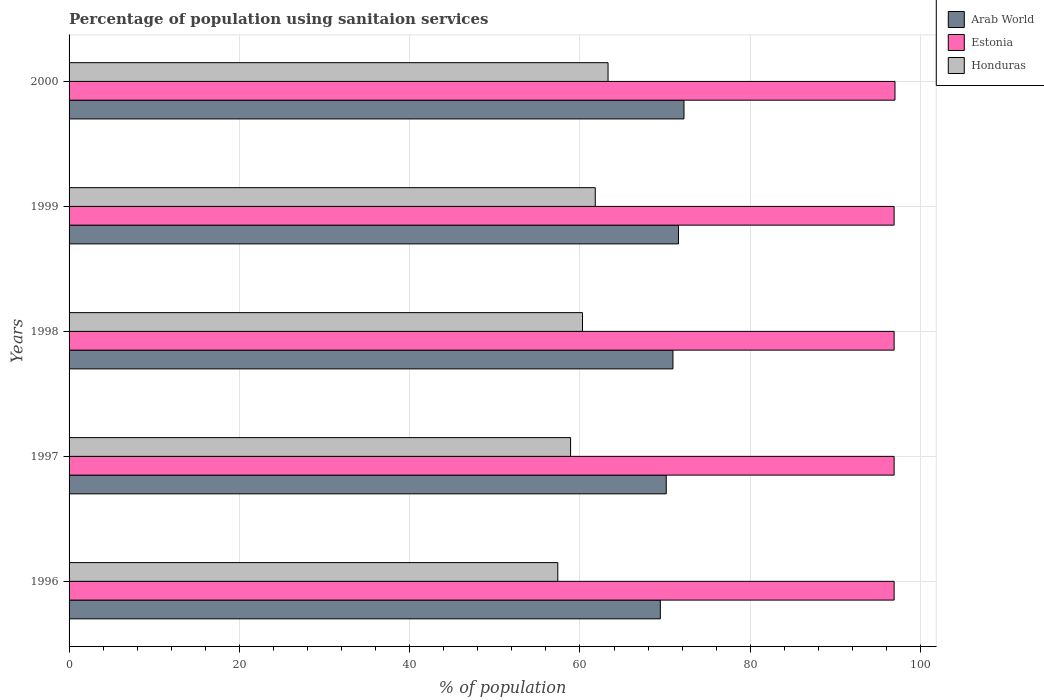How many different coloured bars are there?
Keep it short and to the point. 3. What is the label of the 4th group of bars from the top?
Provide a succinct answer. 1997. What is the percentage of population using sanitaion services in Estonia in 1998?
Provide a succinct answer. 96.9. Across all years, what is the maximum percentage of population using sanitaion services in Estonia?
Your answer should be compact. 97. Across all years, what is the minimum percentage of population using sanitaion services in Arab World?
Ensure brevity in your answer.  69.44. What is the total percentage of population using sanitaion services in Arab World in the graph?
Your response must be concise. 354.29. What is the difference between the percentage of population using sanitaion services in Arab World in 1996 and that in 1997?
Keep it short and to the point. -0.7. What is the difference between the percentage of population using sanitaion services in Honduras in 2000 and the percentage of population using sanitaion services in Arab World in 1997?
Your answer should be very brief. -6.84. What is the average percentage of population using sanitaion services in Honduras per year?
Ensure brevity in your answer.  60.34. In the year 2000, what is the difference between the percentage of population using sanitaion services in Honduras and percentage of population using sanitaion services in Arab World?
Your answer should be very brief. -8.92. In how many years, is the percentage of population using sanitaion services in Arab World greater than 36 %?
Make the answer very short. 5. What is the ratio of the percentage of population using sanitaion services in Honduras in 1997 to that in 1998?
Give a very brief answer. 0.98. What is the difference between the highest and the second highest percentage of population using sanitaion services in Estonia?
Your answer should be very brief. 0.1. What is the difference between the highest and the lowest percentage of population using sanitaion services in Estonia?
Make the answer very short. 0.1. Is the sum of the percentage of population using sanitaion services in Honduras in 1999 and 2000 greater than the maximum percentage of population using sanitaion services in Arab World across all years?
Provide a short and direct response. Yes. What does the 3rd bar from the top in 1998 represents?
Offer a terse response. Arab World. What does the 3rd bar from the bottom in 2000 represents?
Your answer should be compact. Honduras. Are all the bars in the graph horizontal?
Keep it short and to the point. Yes. How many years are there in the graph?
Make the answer very short. 5. Are the values on the major ticks of X-axis written in scientific E-notation?
Give a very brief answer. No. Does the graph contain grids?
Give a very brief answer. Yes. Where does the legend appear in the graph?
Give a very brief answer. Top right. How are the legend labels stacked?
Your response must be concise. Vertical. What is the title of the graph?
Provide a succinct answer. Percentage of population using sanitaion services. Does "Monaco" appear as one of the legend labels in the graph?
Ensure brevity in your answer.  No. What is the label or title of the X-axis?
Provide a succinct answer. % of population. What is the % of population in Arab World in 1996?
Provide a short and direct response. 69.44. What is the % of population in Estonia in 1996?
Provide a succinct answer. 96.9. What is the % of population in Honduras in 1996?
Make the answer very short. 57.4. What is the % of population of Arab World in 1997?
Your answer should be very brief. 70.14. What is the % of population in Estonia in 1997?
Your answer should be very brief. 96.9. What is the % of population in Honduras in 1997?
Provide a succinct answer. 58.9. What is the % of population in Arab World in 1998?
Provide a short and direct response. 70.92. What is the % of population of Estonia in 1998?
Provide a short and direct response. 96.9. What is the % of population in Honduras in 1998?
Provide a succinct answer. 60.3. What is the % of population in Arab World in 1999?
Keep it short and to the point. 71.57. What is the % of population of Estonia in 1999?
Ensure brevity in your answer.  96.9. What is the % of population in Honduras in 1999?
Give a very brief answer. 61.8. What is the % of population in Arab World in 2000?
Provide a succinct answer. 72.22. What is the % of population of Estonia in 2000?
Make the answer very short. 97. What is the % of population of Honduras in 2000?
Ensure brevity in your answer.  63.3. Across all years, what is the maximum % of population of Arab World?
Keep it short and to the point. 72.22. Across all years, what is the maximum % of population in Estonia?
Your answer should be compact. 97. Across all years, what is the maximum % of population of Honduras?
Offer a very short reply. 63.3. Across all years, what is the minimum % of population of Arab World?
Provide a short and direct response. 69.44. Across all years, what is the minimum % of population in Estonia?
Ensure brevity in your answer.  96.9. Across all years, what is the minimum % of population in Honduras?
Give a very brief answer. 57.4. What is the total % of population of Arab World in the graph?
Keep it short and to the point. 354.29. What is the total % of population of Estonia in the graph?
Make the answer very short. 484.6. What is the total % of population of Honduras in the graph?
Make the answer very short. 301.7. What is the difference between the % of population of Arab World in 1996 and that in 1997?
Your response must be concise. -0.7. What is the difference between the % of population in Estonia in 1996 and that in 1997?
Your response must be concise. 0. What is the difference between the % of population of Honduras in 1996 and that in 1997?
Your response must be concise. -1.5. What is the difference between the % of population in Arab World in 1996 and that in 1998?
Give a very brief answer. -1.48. What is the difference between the % of population of Estonia in 1996 and that in 1998?
Ensure brevity in your answer.  0. What is the difference between the % of population in Arab World in 1996 and that in 1999?
Make the answer very short. -2.13. What is the difference between the % of population of Honduras in 1996 and that in 1999?
Ensure brevity in your answer.  -4.4. What is the difference between the % of population of Arab World in 1996 and that in 2000?
Keep it short and to the point. -2.78. What is the difference between the % of population of Estonia in 1996 and that in 2000?
Your answer should be compact. -0.1. What is the difference between the % of population in Arab World in 1997 and that in 1998?
Offer a very short reply. -0.79. What is the difference between the % of population in Arab World in 1997 and that in 1999?
Your response must be concise. -1.44. What is the difference between the % of population of Honduras in 1997 and that in 1999?
Provide a succinct answer. -2.9. What is the difference between the % of population of Arab World in 1997 and that in 2000?
Offer a very short reply. -2.08. What is the difference between the % of population of Estonia in 1997 and that in 2000?
Provide a short and direct response. -0.1. What is the difference between the % of population of Honduras in 1997 and that in 2000?
Ensure brevity in your answer.  -4.4. What is the difference between the % of population of Arab World in 1998 and that in 1999?
Make the answer very short. -0.65. What is the difference between the % of population in Estonia in 1998 and that in 1999?
Your answer should be very brief. 0. What is the difference between the % of population of Arab World in 1998 and that in 2000?
Your answer should be compact. -1.29. What is the difference between the % of population of Arab World in 1999 and that in 2000?
Your answer should be very brief. -0.65. What is the difference between the % of population in Estonia in 1999 and that in 2000?
Ensure brevity in your answer.  -0.1. What is the difference between the % of population in Honduras in 1999 and that in 2000?
Provide a short and direct response. -1.5. What is the difference between the % of population in Arab World in 1996 and the % of population in Estonia in 1997?
Ensure brevity in your answer.  -27.46. What is the difference between the % of population in Arab World in 1996 and the % of population in Honduras in 1997?
Your response must be concise. 10.54. What is the difference between the % of population of Arab World in 1996 and the % of population of Estonia in 1998?
Your response must be concise. -27.46. What is the difference between the % of population of Arab World in 1996 and the % of population of Honduras in 1998?
Give a very brief answer. 9.14. What is the difference between the % of population in Estonia in 1996 and the % of population in Honduras in 1998?
Provide a succinct answer. 36.6. What is the difference between the % of population in Arab World in 1996 and the % of population in Estonia in 1999?
Keep it short and to the point. -27.46. What is the difference between the % of population of Arab World in 1996 and the % of population of Honduras in 1999?
Make the answer very short. 7.64. What is the difference between the % of population of Estonia in 1996 and the % of population of Honduras in 1999?
Your response must be concise. 35.1. What is the difference between the % of population of Arab World in 1996 and the % of population of Estonia in 2000?
Provide a succinct answer. -27.56. What is the difference between the % of population in Arab World in 1996 and the % of population in Honduras in 2000?
Ensure brevity in your answer.  6.14. What is the difference between the % of population in Estonia in 1996 and the % of population in Honduras in 2000?
Your answer should be compact. 33.6. What is the difference between the % of population in Arab World in 1997 and the % of population in Estonia in 1998?
Make the answer very short. -26.76. What is the difference between the % of population of Arab World in 1997 and the % of population of Honduras in 1998?
Your response must be concise. 9.84. What is the difference between the % of population in Estonia in 1997 and the % of population in Honduras in 1998?
Ensure brevity in your answer.  36.6. What is the difference between the % of population of Arab World in 1997 and the % of population of Estonia in 1999?
Offer a very short reply. -26.76. What is the difference between the % of population in Arab World in 1997 and the % of population in Honduras in 1999?
Provide a succinct answer. 8.34. What is the difference between the % of population in Estonia in 1997 and the % of population in Honduras in 1999?
Give a very brief answer. 35.1. What is the difference between the % of population of Arab World in 1997 and the % of population of Estonia in 2000?
Give a very brief answer. -26.86. What is the difference between the % of population in Arab World in 1997 and the % of population in Honduras in 2000?
Offer a very short reply. 6.84. What is the difference between the % of population of Estonia in 1997 and the % of population of Honduras in 2000?
Ensure brevity in your answer.  33.6. What is the difference between the % of population in Arab World in 1998 and the % of population in Estonia in 1999?
Ensure brevity in your answer.  -25.98. What is the difference between the % of population of Arab World in 1998 and the % of population of Honduras in 1999?
Keep it short and to the point. 9.12. What is the difference between the % of population of Estonia in 1998 and the % of population of Honduras in 1999?
Give a very brief answer. 35.1. What is the difference between the % of population of Arab World in 1998 and the % of population of Estonia in 2000?
Provide a succinct answer. -26.08. What is the difference between the % of population of Arab World in 1998 and the % of population of Honduras in 2000?
Make the answer very short. 7.62. What is the difference between the % of population in Estonia in 1998 and the % of population in Honduras in 2000?
Make the answer very short. 33.6. What is the difference between the % of population in Arab World in 1999 and the % of population in Estonia in 2000?
Provide a short and direct response. -25.43. What is the difference between the % of population in Arab World in 1999 and the % of population in Honduras in 2000?
Offer a very short reply. 8.27. What is the difference between the % of population of Estonia in 1999 and the % of population of Honduras in 2000?
Provide a succinct answer. 33.6. What is the average % of population in Arab World per year?
Provide a short and direct response. 70.86. What is the average % of population of Estonia per year?
Your response must be concise. 96.92. What is the average % of population of Honduras per year?
Provide a succinct answer. 60.34. In the year 1996, what is the difference between the % of population in Arab World and % of population in Estonia?
Ensure brevity in your answer.  -27.46. In the year 1996, what is the difference between the % of population in Arab World and % of population in Honduras?
Make the answer very short. 12.04. In the year 1996, what is the difference between the % of population of Estonia and % of population of Honduras?
Keep it short and to the point. 39.5. In the year 1997, what is the difference between the % of population in Arab World and % of population in Estonia?
Make the answer very short. -26.76. In the year 1997, what is the difference between the % of population in Arab World and % of population in Honduras?
Provide a succinct answer. 11.24. In the year 1998, what is the difference between the % of population in Arab World and % of population in Estonia?
Provide a short and direct response. -25.98. In the year 1998, what is the difference between the % of population in Arab World and % of population in Honduras?
Offer a terse response. 10.62. In the year 1998, what is the difference between the % of population of Estonia and % of population of Honduras?
Ensure brevity in your answer.  36.6. In the year 1999, what is the difference between the % of population of Arab World and % of population of Estonia?
Make the answer very short. -25.33. In the year 1999, what is the difference between the % of population in Arab World and % of population in Honduras?
Provide a succinct answer. 9.77. In the year 1999, what is the difference between the % of population of Estonia and % of population of Honduras?
Give a very brief answer. 35.1. In the year 2000, what is the difference between the % of population of Arab World and % of population of Estonia?
Your response must be concise. -24.78. In the year 2000, what is the difference between the % of population of Arab World and % of population of Honduras?
Ensure brevity in your answer.  8.92. In the year 2000, what is the difference between the % of population in Estonia and % of population in Honduras?
Offer a very short reply. 33.7. What is the ratio of the % of population in Arab World in 1996 to that in 1997?
Provide a succinct answer. 0.99. What is the ratio of the % of population of Estonia in 1996 to that in 1997?
Give a very brief answer. 1. What is the ratio of the % of population of Honduras in 1996 to that in 1997?
Your answer should be compact. 0.97. What is the ratio of the % of population of Arab World in 1996 to that in 1998?
Provide a short and direct response. 0.98. What is the ratio of the % of population of Estonia in 1996 to that in 1998?
Your response must be concise. 1. What is the ratio of the % of population of Honduras in 1996 to that in 1998?
Your answer should be very brief. 0.95. What is the ratio of the % of population in Arab World in 1996 to that in 1999?
Your answer should be very brief. 0.97. What is the ratio of the % of population of Estonia in 1996 to that in 1999?
Offer a very short reply. 1. What is the ratio of the % of population in Honduras in 1996 to that in 1999?
Your answer should be compact. 0.93. What is the ratio of the % of population in Arab World in 1996 to that in 2000?
Keep it short and to the point. 0.96. What is the ratio of the % of population of Honduras in 1996 to that in 2000?
Make the answer very short. 0.91. What is the ratio of the % of population in Arab World in 1997 to that in 1998?
Your answer should be very brief. 0.99. What is the ratio of the % of population of Estonia in 1997 to that in 1998?
Give a very brief answer. 1. What is the ratio of the % of population of Honduras in 1997 to that in 1998?
Give a very brief answer. 0.98. What is the ratio of the % of population in Arab World in 1997 to that in 1999?
Your response must be concise. 0.98. What is the ratio of the % of population in Honduras in 1997 to that in 1999?
Your answer should be compact. 0.95. What is the ratio of the % of population in Arab World in 1997 to that in 2000?
Offer a very short reply. 0.97. What is the ratio of the % of population in Estonia in 1997 to that in 2000?
Your answer should be compact. 1. What is the ratio of the % of population in Honduras in 1997 to that in 2000?
Give a very brief answer. 0.93. What is the ratio of the % of population of Arab World in 1998 to that in 1999?
Provide a succinct answer. 0.99. What is the ratio of the % of population in Estonia in 1998 to that in 1999?
Your answer should be compact. 1. What is the ratio of the % of population of Honduras in 1998 to that in 1999?
Your answer should be very brief. 0.98. What is the ratio of the % of population in Arab World in 1998 to that in 2000?
Ensure brevity in your answer.  0.98. What is the ratio of the % of population in Honduras in 1998 to that in 2000?
Keep it short and to the point. 0.95. What is the ratio of the % of population in Arab World in 1999 to that in 2000?
Make the answer very short. 0.99. What is the ratio of the % of population of Honduras in 1999 to that in 2000?
Your response must be concise. 0.98. What is the difference between the highest and the second highest % of population in Arab World?
Provide a short and direct response. 0.65. What is the difference between the highest and the second highest % of population of Estonia?
Your response must be concise. 0.1. What is the difference between the highest and the second highest % of population in Honduras?
Your answer should be very brief. 1.5. What is the difference between the highest and the lowest % of population of Arab World?
Your response must be concise. 2.78. What is the difference between the highest and the lowest % of population in Estonia?
Provide a short and direct response. 0.1. 